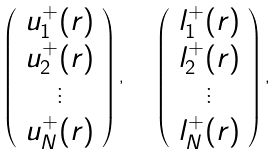Convert formula to latex. <formula><loc_0><loc_0><loc_500><loc_500>\left ( \begin{array} { c } u _ { 1 } ^ { + } ( r ) \\ u _ { 2 } ^ { + } ( r ) \\ \vdots \\ u _ { N } ^ { + } ( r ) \end{array} \right ) , \quad \left ( \begin{array} { c } l _ { 1 } ^ { + } ( r ) \\ l _ { 2 } ^ { + } ( r ) \\ \vdots \\ l _ { N } ^ { + } ( r ) \end{array} \right ) ,</formula> 